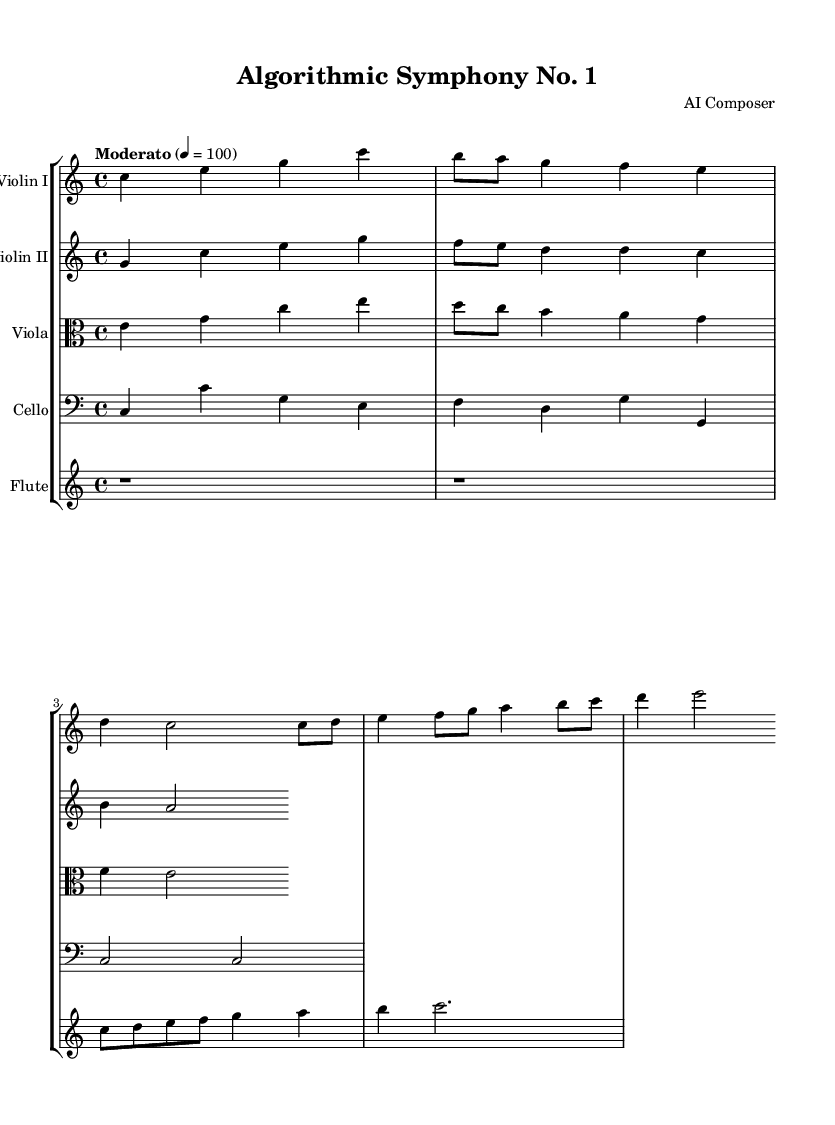What is the key signature of this music? The key signature is C major, which has no sharps or flats.
Answer: C major What is the time signature of this piece? The time signature is indicated at the beginning of the score, showing four beats per measure (4/4).
Answer: 4/4 What is the tempo marking for the symphony? The tempo marking is specified as "Moderato," which signifies a moderate pace, typically around 100 beats per minute.
Answer: Moderato How many instruments are there in this symphony? The score lists a total of five different instruments: two violins, a viola, a cello, and a flute.
Answer: Five What is the main theme's starting note for Violin I? Observing the Violin I part, the main theme starts on the note C, which is the first note presented in the series.
Answer: C Which mathematical concept inspired the rhythm in Violin I? The rhythm in Violin I incorporates elements from the Fibonacci sequence, as indicated by the note values displayed in the rhythm.
Answer: Fibonacci What kind of melody does the flute play? The flute plays a melody that is inspired by fractals, as made clear in the description of its part, which suggests repeating and intricate patterns.
Answer: Fractal-inspired 